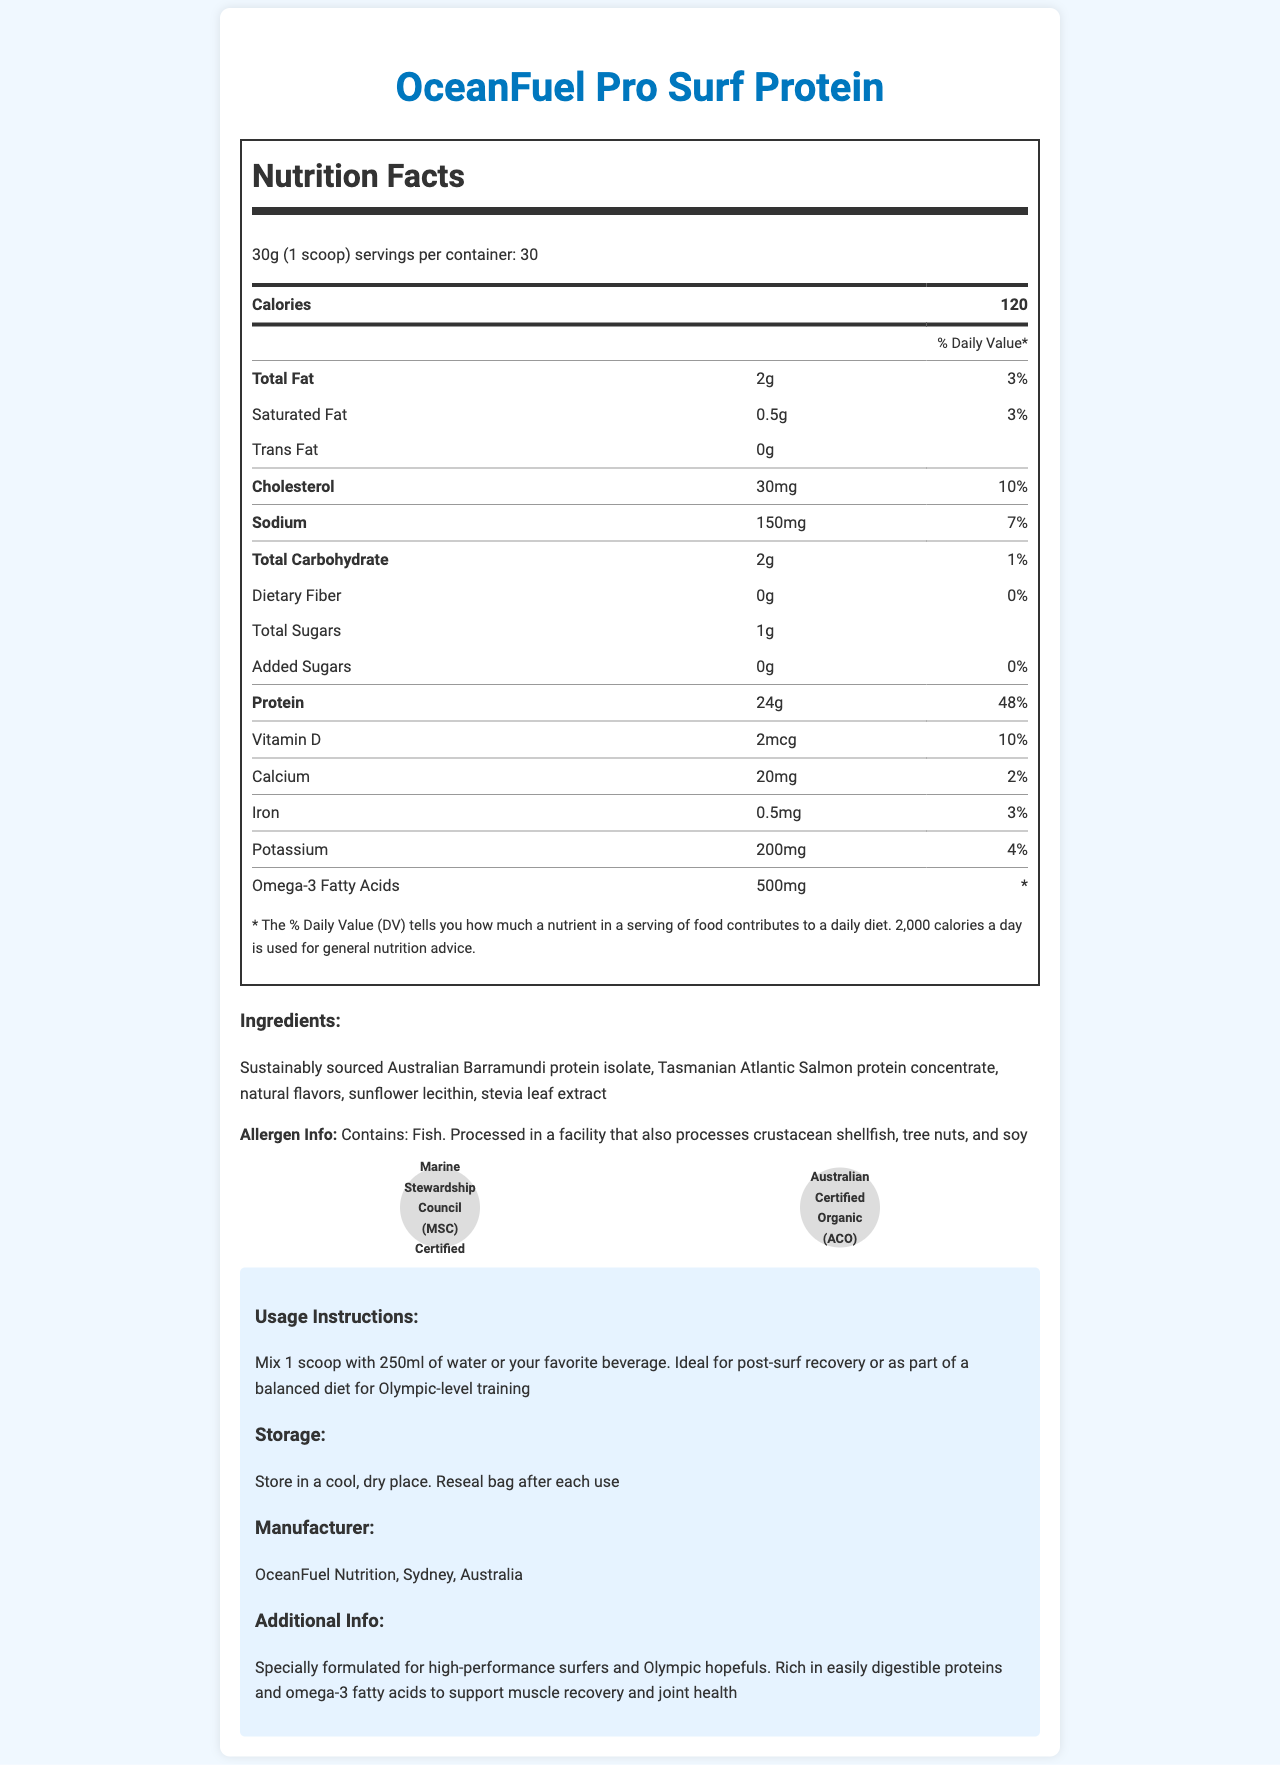What is the serving size of OceanFuel Pro Surf Protein? According to the document, the serving size is clearly mentioned as 30g (1 scoop).
Answer: 30g (1 scoop) How many servings are there per container? The document states that there are 30 servings per container.
Answer: 30 How many calories are in one serving of the protein powder? The document specifies that each serving contains 120 calories.
Answer: 120 What percentage of the Daily Value is the total fat content per serving? The document lists the total fat content as 2g, which is 3% of the Daily Value.
Answer: 3% What is the amount of protein per serving? The label indicates that there are 24g of protein per serving.
Answer: 24g Does the OceanFuel Pro Surf Protein contain any trans fat? The label clearly shows that trans fat content is 0g.
Answer: No How much sodium is in one serving? The document states there are 150mg of sodium in each serving.
Answer: 150mg Which certifications does this product have? A. USDA Organic B. Marine Stewardship Council C. Australian Certified Organic D. Non-GMO Verified The document lists "Marine Stewardship Council (MSC) Certified" and "Australian Certified Organic (ACO)" as the certifications.
Answer: B, C What allergens does this product contain? A. Nuts B. Fish C. Dairy D. Wheat The document states that it contains fish and is processed in a facility that also processes crustacean shellfish, tree nuts, and soy.
Answer: B What is the manufacturer's location? The document specifies that the manufacturer is OceanFuel Nutrition located in Sydney, Australia.
Answer: Sydney, Australia What type of protein sources are used in this product? The ingredient list specifies that these are the protein sources used.
Answer: Sustainably sourced Australian Barramundi protein isolate, Tasmanian Atlantic Salmon protein concentrate Is this protein powder suitable for someone looking to avoid added sugars? The label indicates that there are 0g of added sugars in the product.
Answer: Yes What is the recommended usage for this protein powder? The usage instructions are clearly stated in the document.
Answer: Mix 1 scoop with 250ml of water or your favorite beverage. Ideal for post-surf recovery or as part of a balanced diet for Olympic-level training What is the total carbohydrate content per serving? The label mentions that each serving contains 2g of total carbohydrate.
Answer: 2g Does the product contain any dietary fiber? The document specifies that the dietary fiber content is 0g.
Answer: No Summarize the main idea of the document. The document includes detailed nutrition facts, ingredient information, certifications, usage instructions, allergen info, and storage instructions.
Answer: OceanFuel Pro Surf Protein is a fish-based protein powder designed for high-performance surfers and Olympic hopefuls, offering high protein content, omega-3 fatty acids, and sustainability certifications. It is free from added sugars and processed in a facility with certain allergens. How is the product stored? The storage instructions are clearly mentioned in the document.
Answer: Store in a cool, dry place. Reseal bag after each use. How much potassium is in one serving? The label indicates that there are 200mg of potassium per serving.
Answer: 200mg What is the recommended amount of water or beverage to mix with one scoop for optimal usage? The usage instructions state that one scoop should be mixed with 250ml of water or your favorite beverage.
Answer: 250ml What is the recommended daily intake of omega-3 fatty acids from this product? The document states the amount of omega-3 fatty acids per serving (500mg) but does not provide a recommended daily intake.
Answer: Not enough information Is the OceanFuel Pro Surf Protein Marine Stewardship Council (MSC) certified? The product is certified by the Marine Stewardship Council as mentioned in the document.
Answer: Yes 